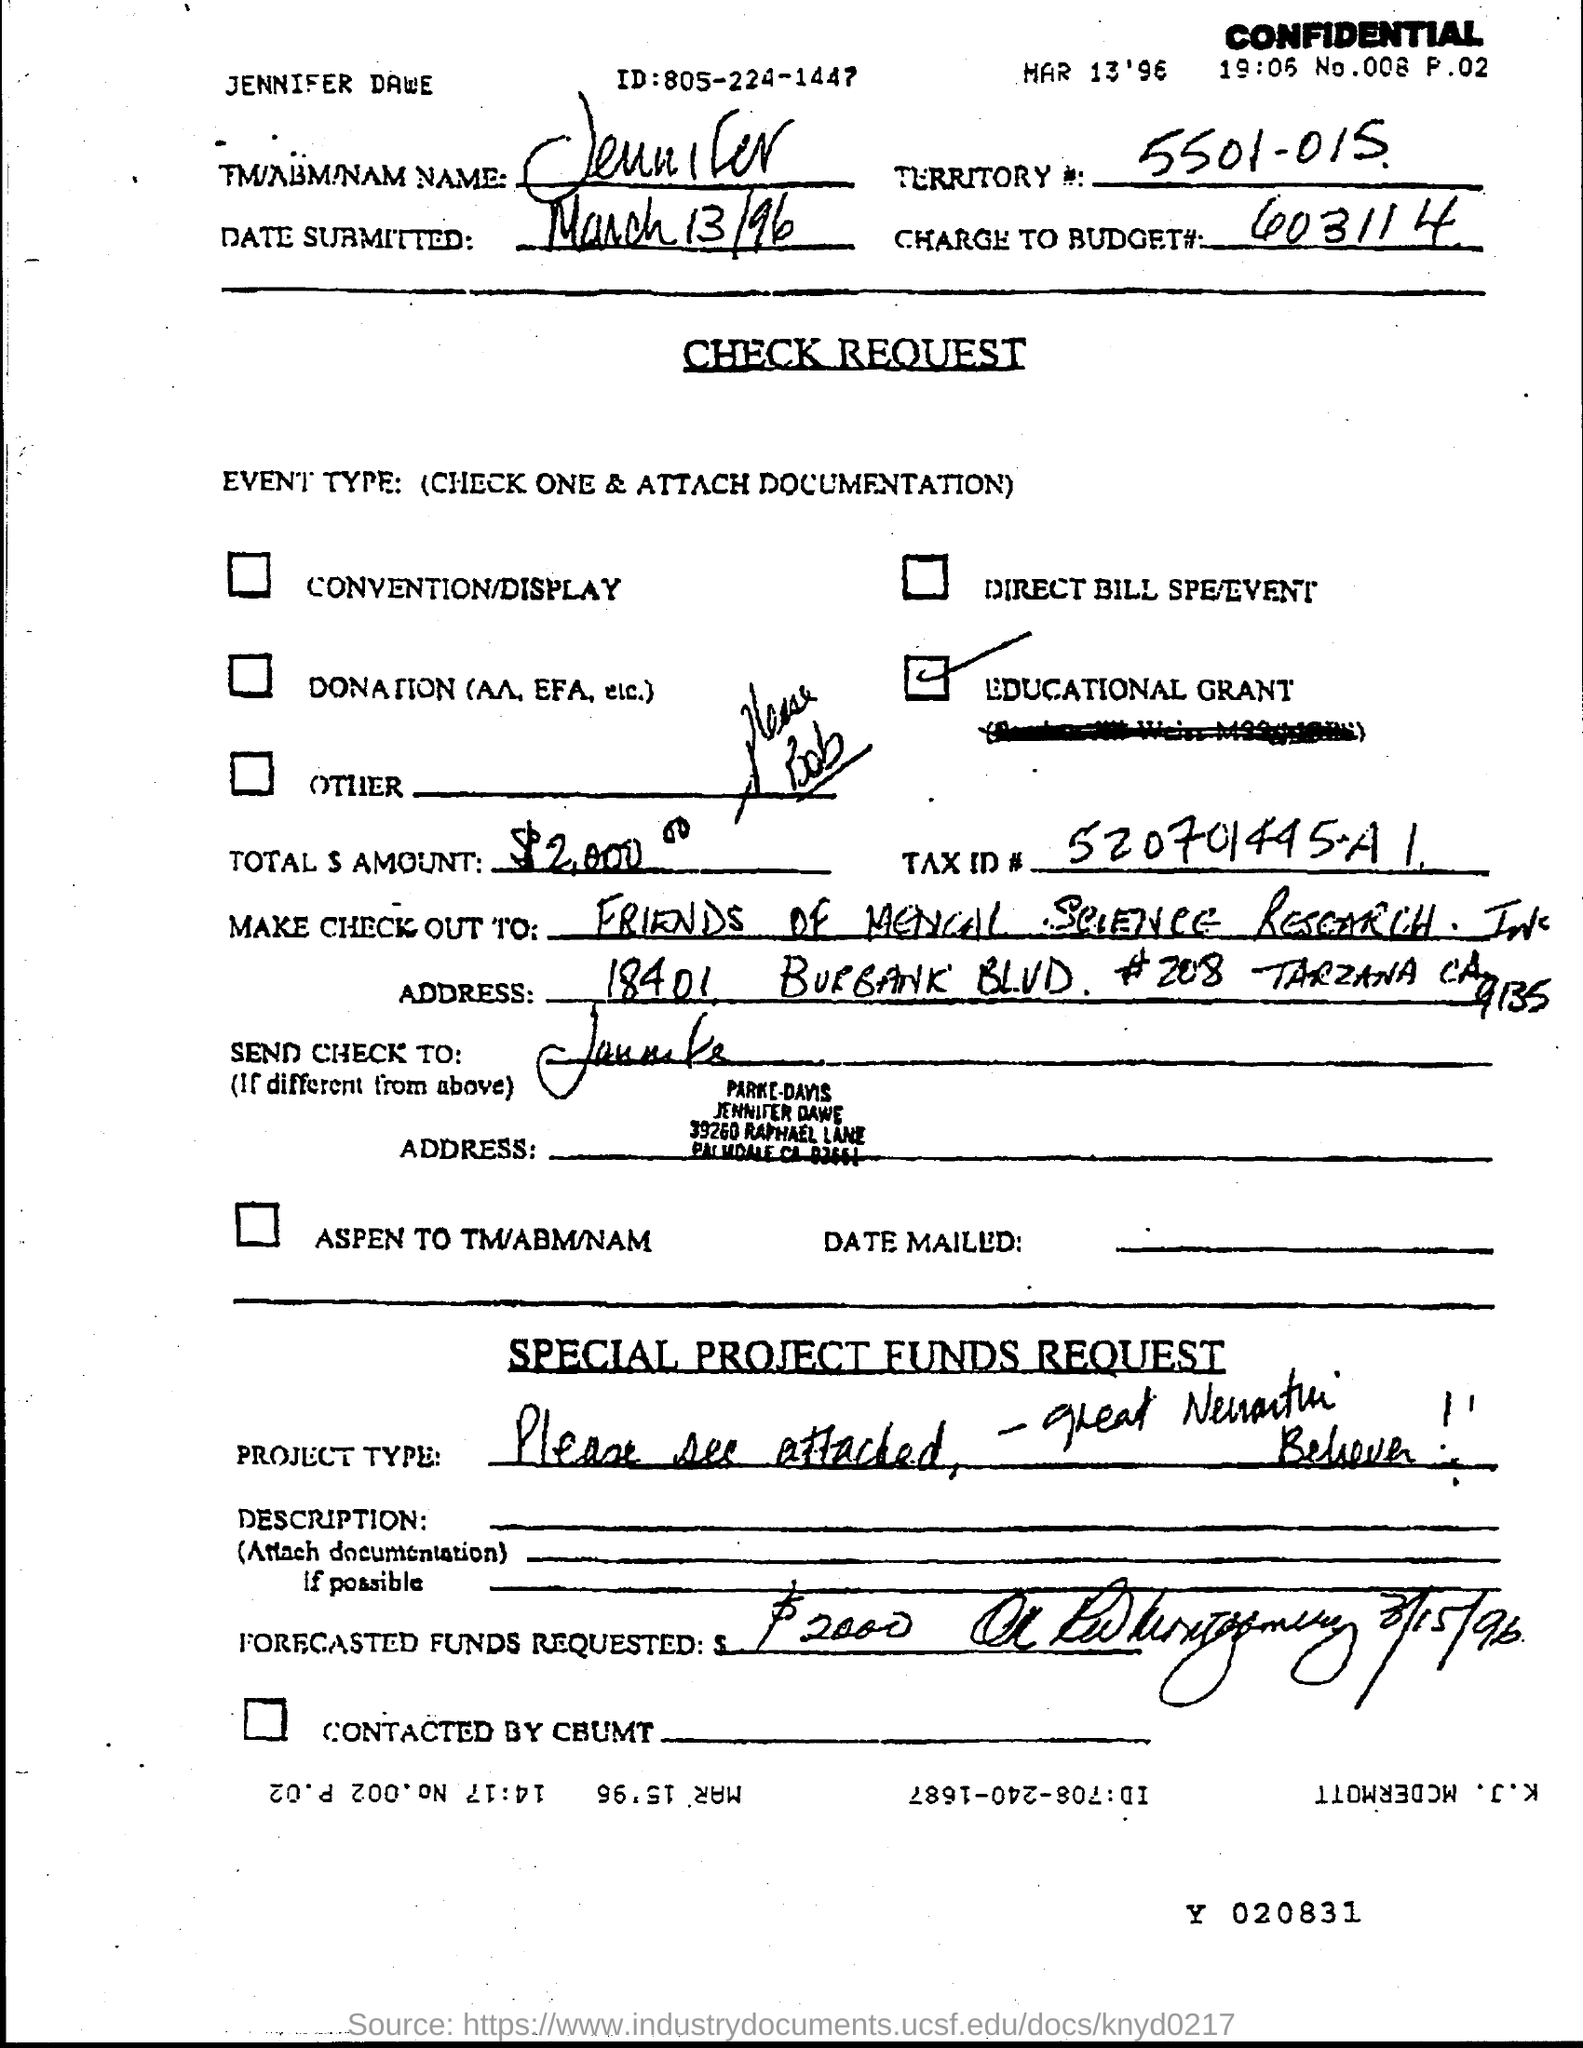Highlight a few significant elements in this photo. The ID is 805-224-1447. What is the Tax ID number? It is 520701445-A1. The number 5501 is the territory, and the letter 'A' is the first character in the identifier, followed by the letter 'P' in the second position. The charge to budget number 603114 is. 